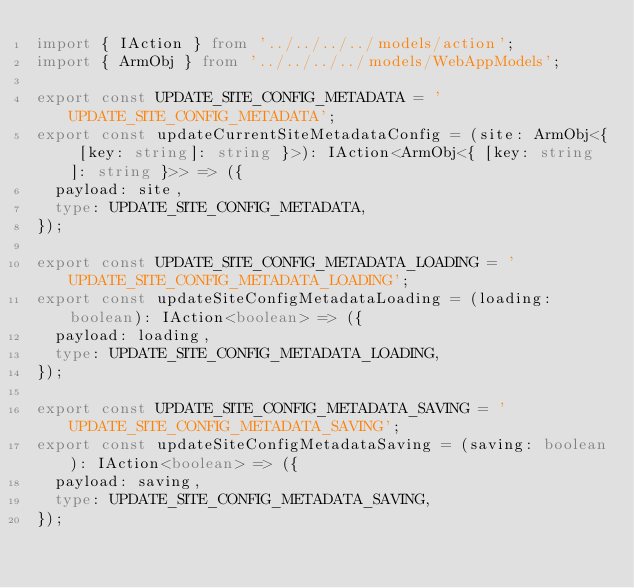Convert code to text. <code><loc_0><loc_0><loc_500><loc_500><_TypeScript_>import { IAction } from '../../../../models/action';
import { ArmObj } from '../../../../models/WebAppModels';

export const UPDATE_SITE_CONFIG_METADATA = 'UPDATE_SITE_CONFIG_METADATA';
export const updateCurrentSiteMetadataConfig = (site: ArmObj<{ [key: string]: string }>): IAction<ArmObj<{ [key: string]: string }>> => ({
  payload: site,
  type: UPDATE_SITE_CONFIG_METADATA,
});

export const UPDATE_SITE_CONFIG_METADATA_LOADING = 'UPDATE_SITE_CONFIG_METADATA_LOADING';
export const updateSiteConfigMetadataLoading = (loading: boolean): IAction<boolean> => ({
  payload: loading,
  type: UPDATE_SITE_CONFIG_METADATA_LOADING,
});

export const UPDATE_SITE_CONFIG_METADATA_SAVING = 'UPDATE_SITE_CONFIG_METADATA_SAVING';
export const updateSiteConfigMetadataSaving = (saving: boolean): IAction<boolean> => ({
  payload: saving,
  type: UPDATE_SITE_CONFIG_METADATA_SAVING,
});
</code> 